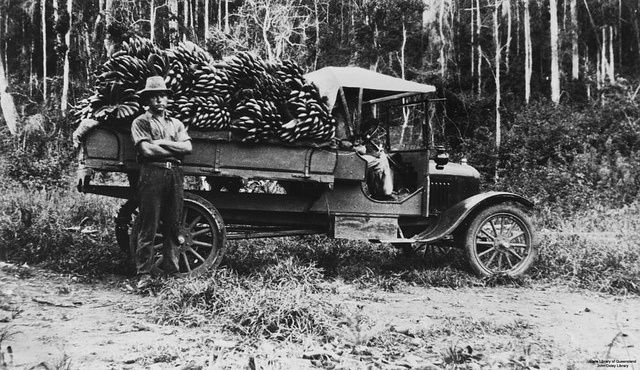Describe the objects in this image and their specific colors. I can see truck in gray, black, darkgray, and lightgray tones, people in gray, black, darkgray, and lightgray tones, banana in gray, black, darkgray, and lightgray tones, banana in gray, black, darkgray, and lightgray tones, and banana in gray, black, darkgray, and lightgray tones in this image. 